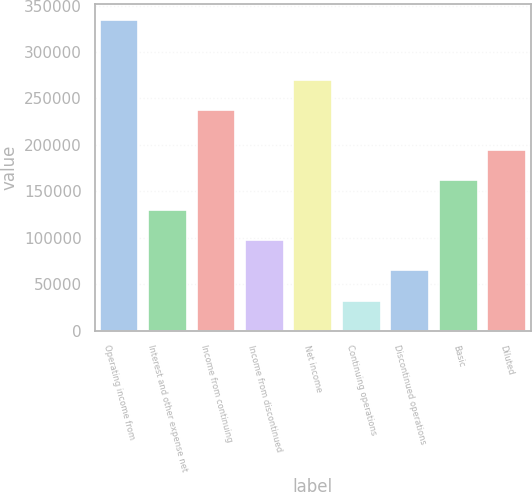<chart> <loc_0><loc_0><loc_500><loc_500><bar_chart><fcel>Operating income from<fcel>Interest and other expense net<fcel>Income from continuing<fcel>Income from discontinued<fcel>Net income<fcel>Continuing operations<fcel>Discontinued operations<fcel>Basic<fcel>Diluted<nl><fcel>334640<fcel>129554<fcel>237475<fcel>97165.4<fcel>269863<fcel>32388.7<fcel>64777<fcel>161942<fcel>194330<nl></chart> 